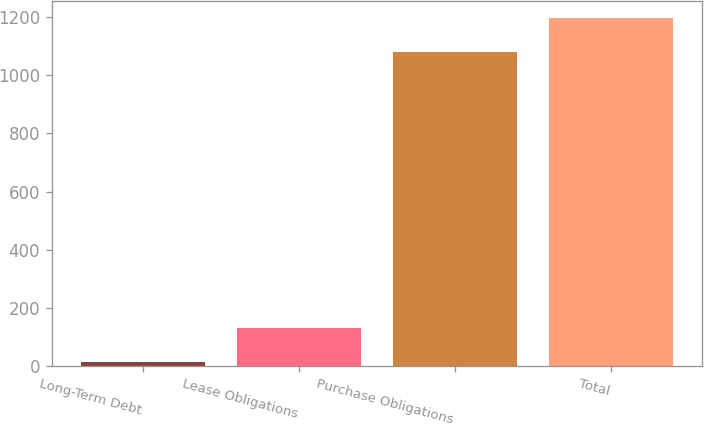<chart> <loc_0><loc_0><loc_500><loc_500><bar_chart><fcel>Long-Term Debt<fcel>Lease Obligations<fcel>Purchase Obligations<fcel>Total<nl><fcel>15.4<fcel>132.18<fcel>1078.6<fcel>1195.38<nl></chart> 